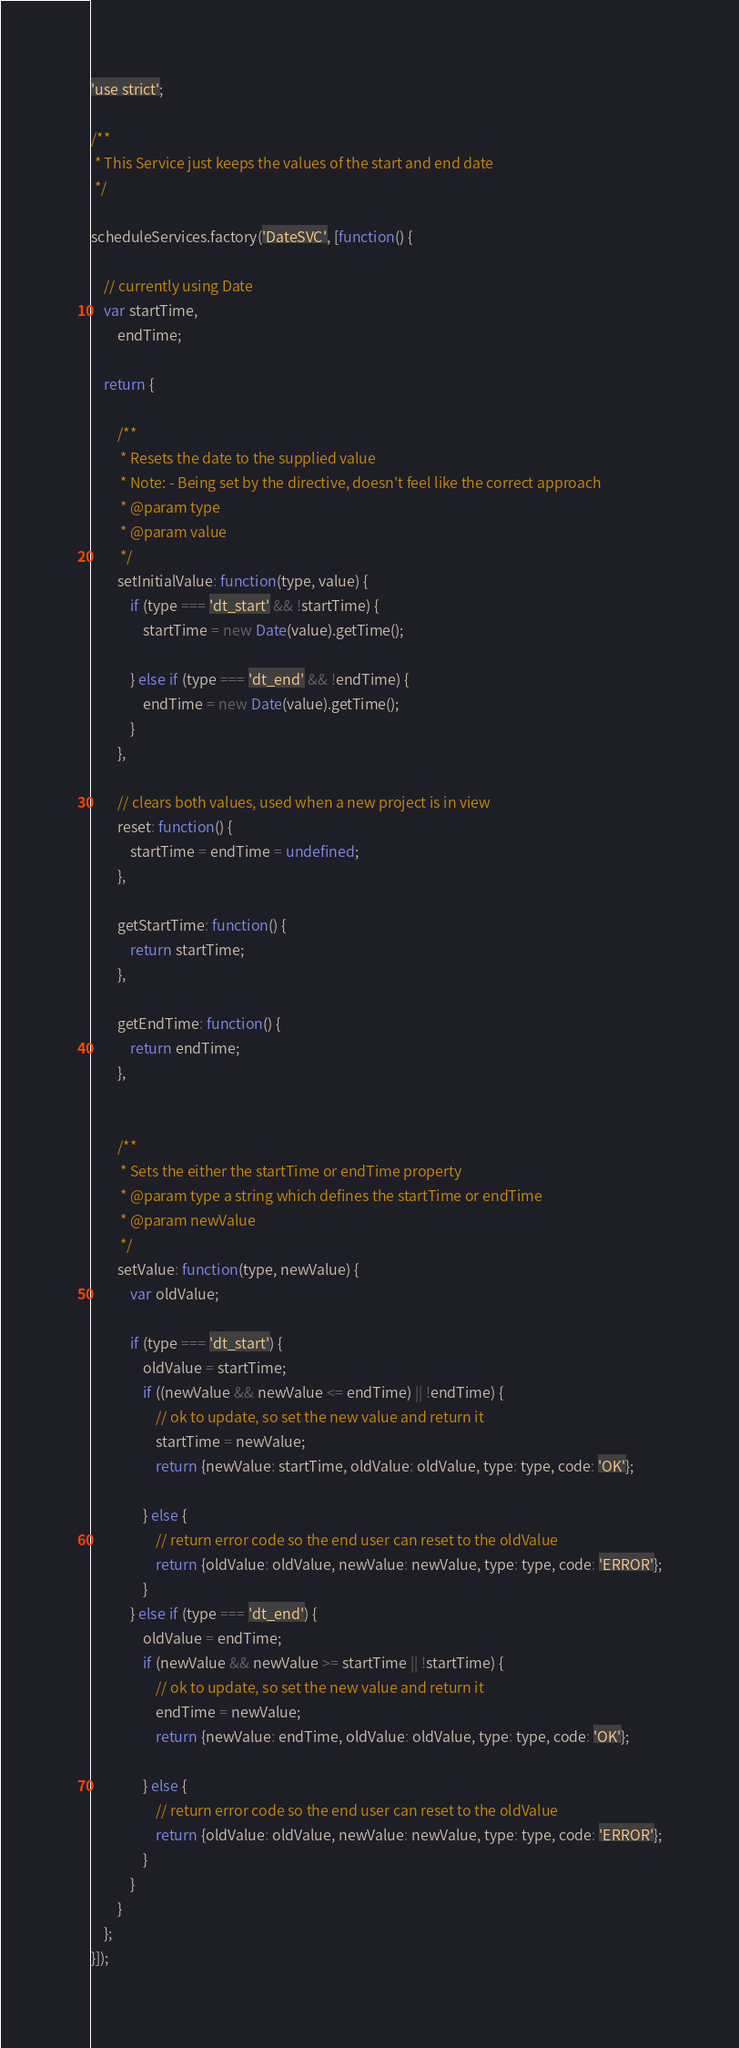Convert code to text. <code><loc_0><loc_0><loc_500><loc_500><_JavaScript_>'use strict';

/**
 * This Service just keeps the values of the start and end date
 */

scheduleServices.factory('DateSVC', [function() {

    // currently using Date
    var startTime,
        endTime;

    return {

        /**
         * Resets the date to the supplied value
         * Note: - Being set by the directive, doesn't feel like the correct approach
         * @param type
         * @param value
         */
        setInitialValue: function(type, value) {
            if (type === 'dt_start' && !startTime) {
                startTime = new Date(value).getTime();

            } else if (type === 'dt_end' && !endTime) {
                endTime = new Date(value).getTime();
            }
        },

        // clears both values, used when a new project is in view
        reset: function() {
            startTime = endTime = undefined;
        },

        getStartTime: function() {
            return startTime;
        },

        getEndTime: function() {
            return endTime;
        },


        /**
         * Sets the either the startTime or endTime property
         * @param type a string which defines the startTime or endTime
         * @param newValue
         */
        setValue: function(type, newValue) {
            var oldValue;

            if (type === 'dt_start') {
                oldValue = startTime;
                if ((newValue && newValue <= endTime) || !endTime) {
                    // ok to update, so set the new value and return it
                    startTime = newValue;
                    return {newValue: startTime, oldValue: oldValue, type: type, code: 'OK'};

                } else {
                    // return error code so the end user can reset to the oldValue
                    return {oldValue: oldValue, newValue: newValue, type: type, code: 'ERROR'};
                }
            } else if (type === 'dt_end') {
                oldValue = endTime;
                if (newValue && newValue >= startTime || !startTime) {
                    // ok to update, so set the new value and return it
                    endTime = newValue;
                    return {newValue: endTime, oldValue: oldValue, type: type, code: 'OK'};

                } else {
                    // return error code so the end user can reset to the oldValue
                    return {oldValue: oldValue, newValue: newValue, type: type, code: 'ERROR'};
                }
            }
        }
    };
}]);
</code> 